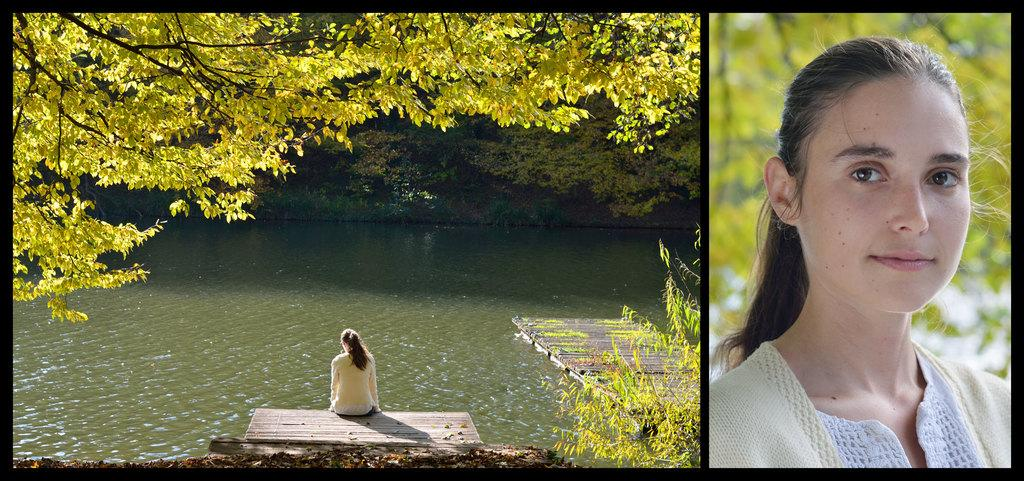What is on the right side of the image? There is a man's face on the right side of the image. What is the girl doing on the left side of the image? There is a girl sitting at the water on the left side of the image. What can be seen in the background of the image? There are trees visible in the background of the image. How many magic spiders are crawling on the man's face in the image? There are no magic spiders present in the image; it only features a man's face and a girl sitting at the water. 